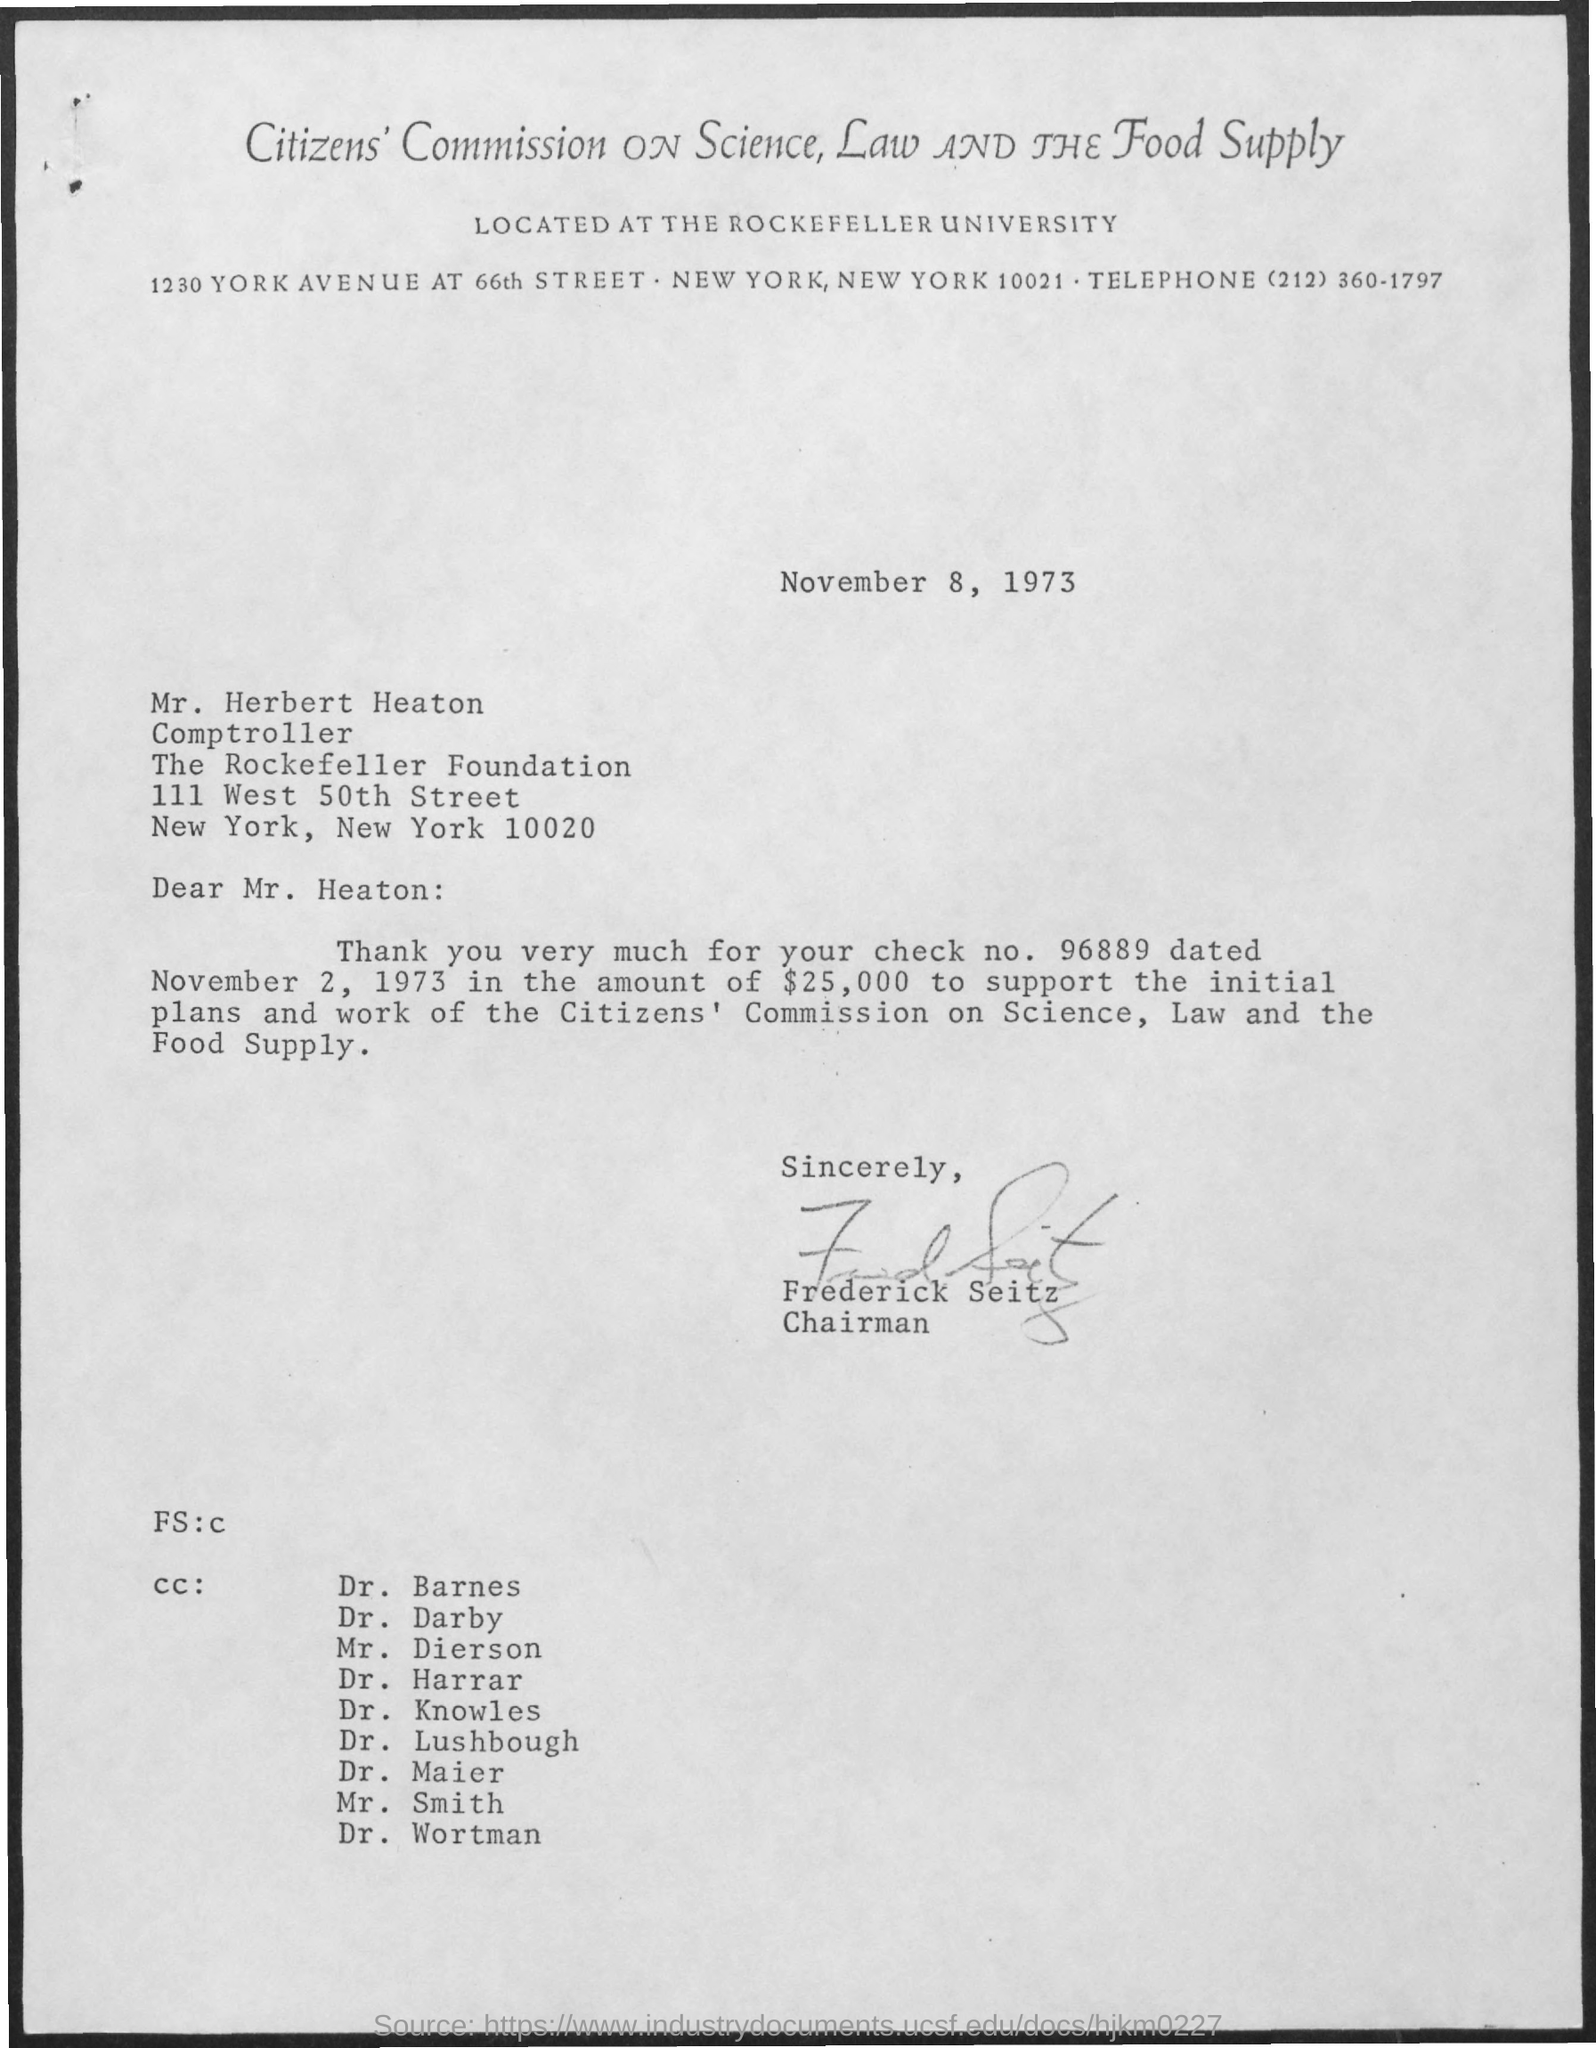Mention a couple of crucial points in this snapshot. The check is dated on November 2, 1973. The date on the document is November 8, 1973. The letter is from Frederick Seitz. This letter is addressed to Mr. Herbert Heaton. The amount is $25,000. 